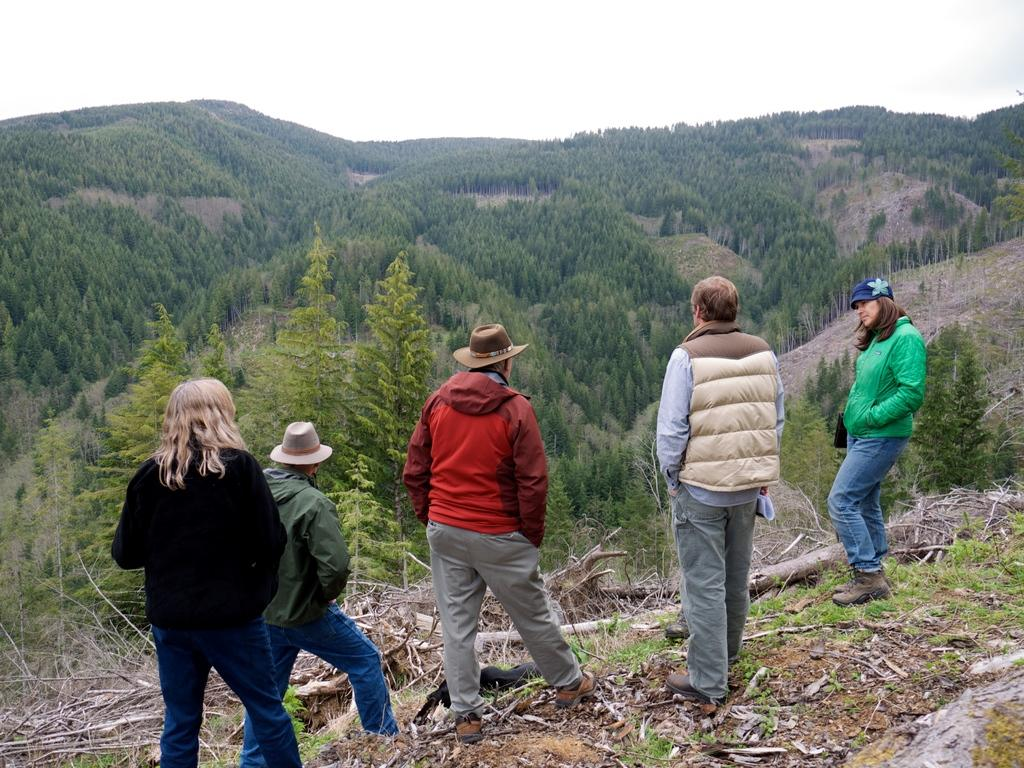What are the people in the image doing? The people in the image are standing on the ground. What else can be seen on the ground in the image? There are fallen objects on the ground in the image. What type of natural environment is visible in the image? There are trees and mountains visible in the image. What is visible above the ground in the image? The sky is visible in the image. How many kittens are playing on the mountains in the image? There are no kittens present in the image, and therefore no such activity can be observed. What type of pig can be seen walking in the mountains in the image? There is no pig present in the image, and therefore no such activity can be observed. 